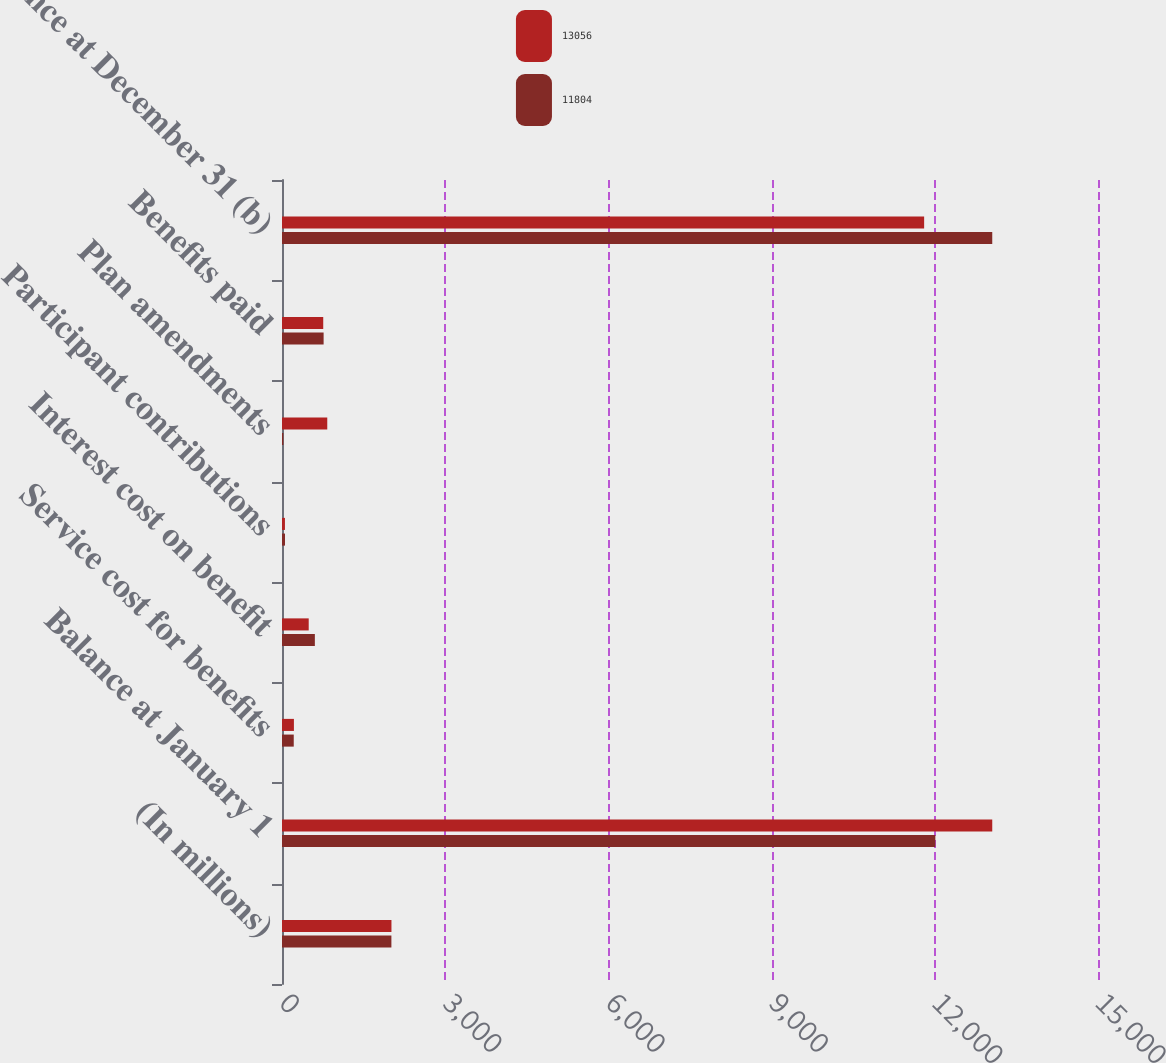Convert chart. <chart><loc_0><loc_0><loc_500><loc_500><stacked_bar_chart><ecel><fcel>(In millions)<fcel>Balance at January 1<fcel>Service cost for benefits<fcel>Interest cost on benefit<fcel>Participant contributions<fcel>Plan amendments<fcel>Benefits paid<fcel>Balance at December 31 (b)<nl><fcel>13056<fcel>2012<fcel>13056<fcel>219<fcel>491<fcel>54<fcel>832<fcel>758<fcel>11804<nl><fcel>11804<fcel>2011<fcel>12010<fcel>216<fcel>604<fcel>55<fcel>25<fcel>765<fcel>13056<nl></chart> 